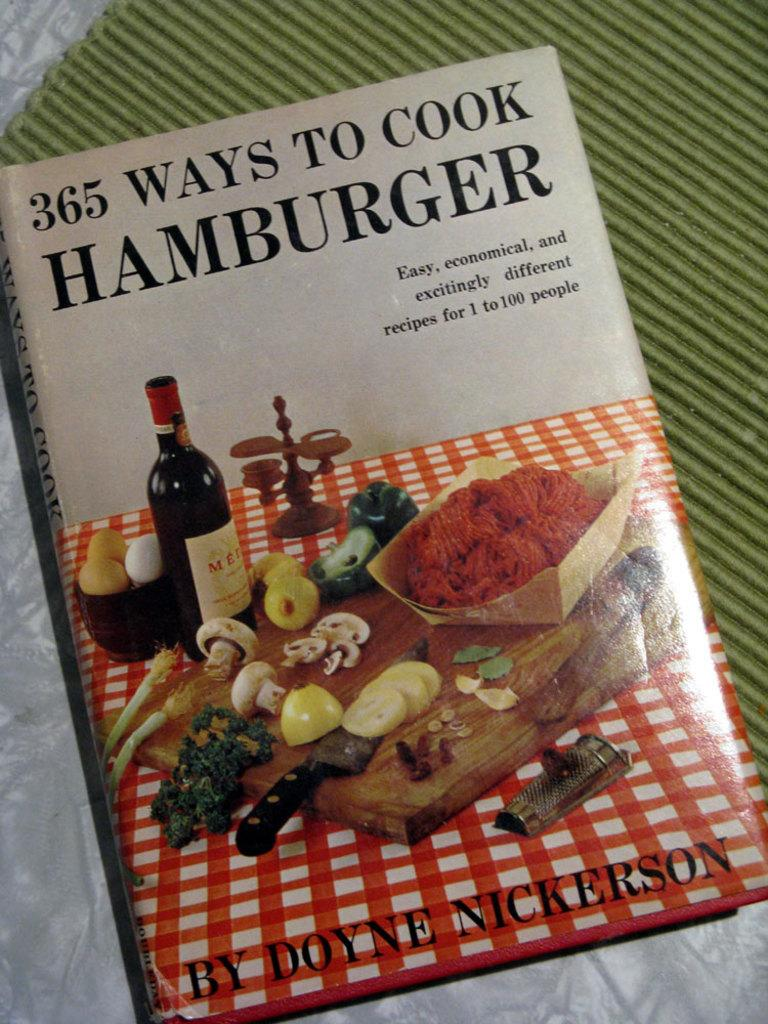<image>
Present a compact description of the photo's key features. A cook book that shows how to cook Hamburger. 